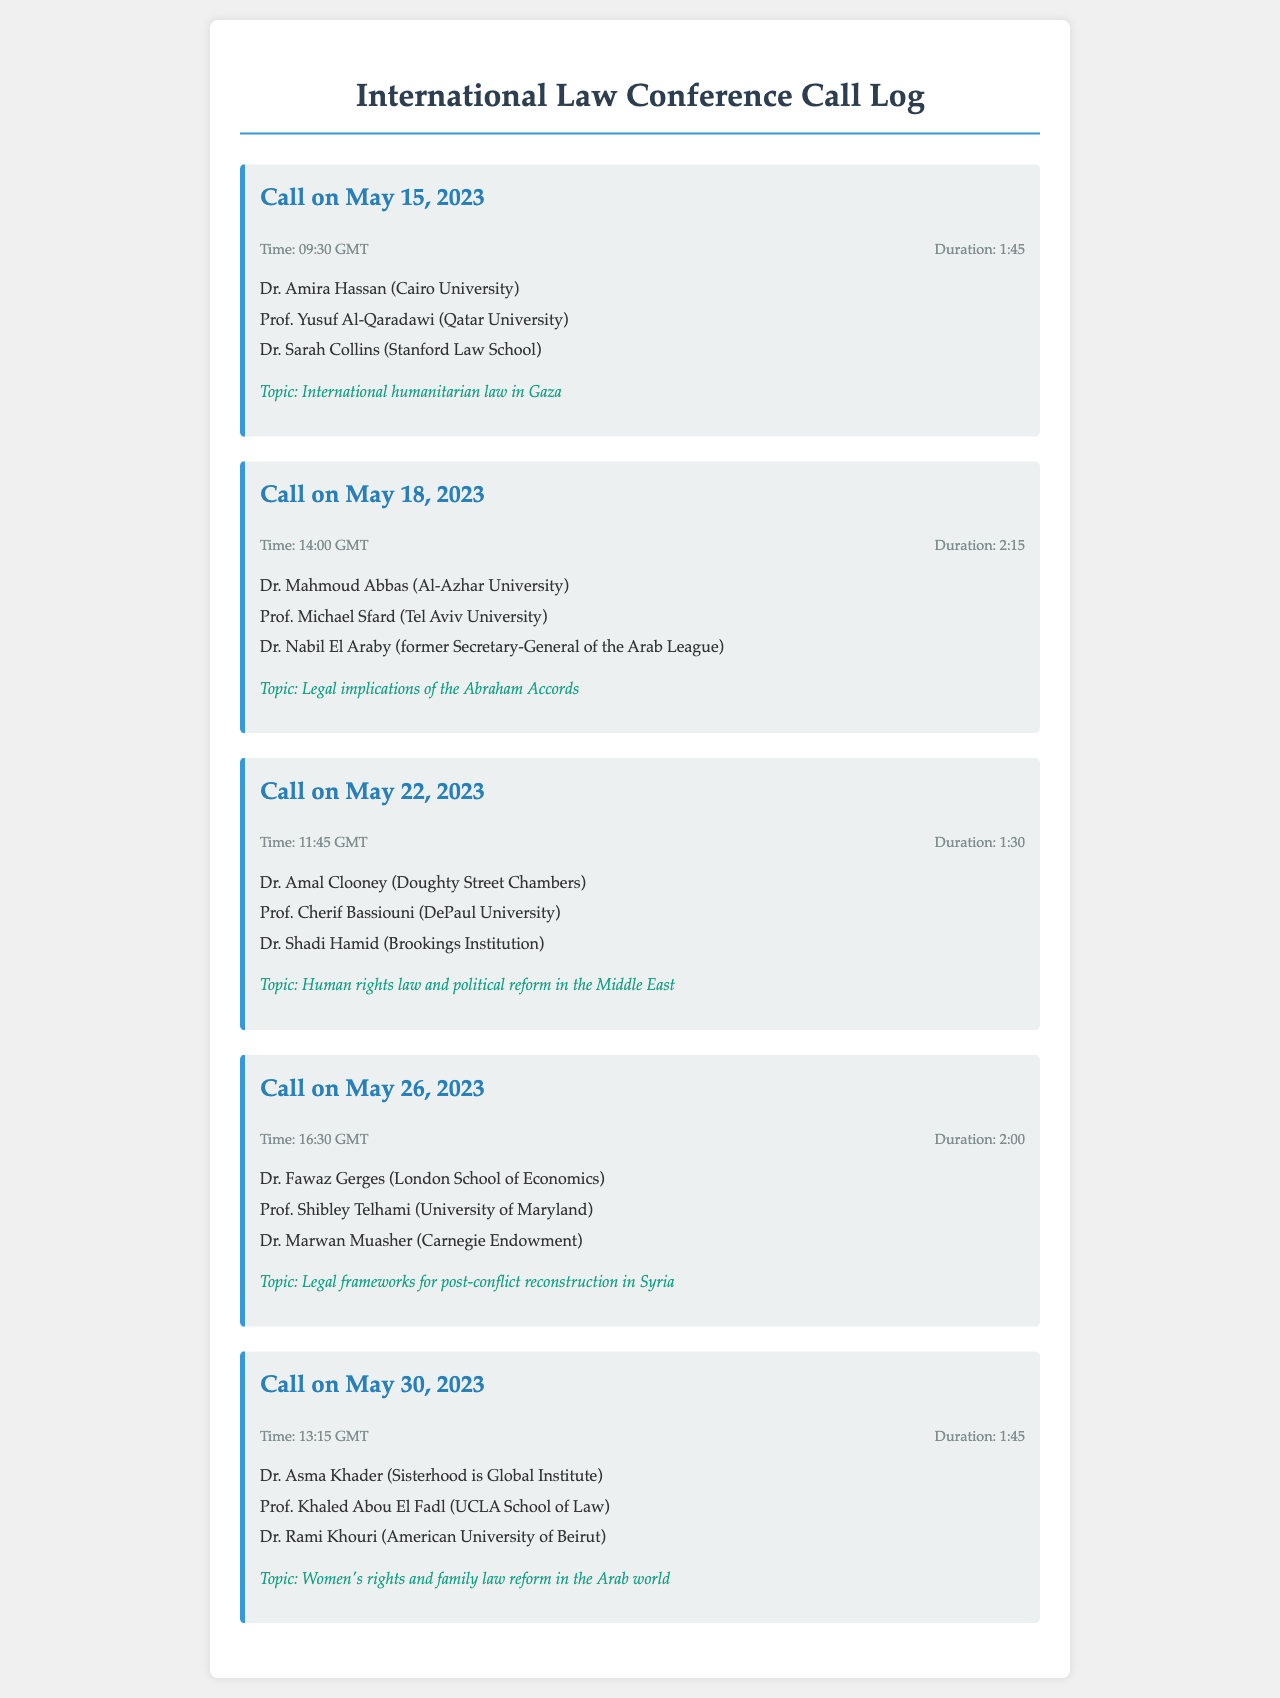What is the duration of the call on May 15, 2023? The duration of the call on May 15, 2023, is specified in the document as 1:45.
Answer: 1:45 Who participated in the discussion about international humanitarian law in Gaza? The participants of the call on May 15, 2023, are listed in the document as Dr. Amira Hassan, Prof. Yusuf Al-Qaradawi, and Dr. Sarah Collins.
Answer: Dr. Amira Hassan, Prof. Yusuf Al-Qaradawi, Dr. Sarah Collins What was the topic of the call held on May 26, 2023? The document specifies that the topic of the call on May 26, 2023, is legal frameworks for post-conflict reconstruction in Syria.
Answer: Legal frameworks for post-conflict reconstruction in Syria Which professor participated in the call regarding women's rights and family law reform? The document indicates that Prof. Khaled Abou El Fadl participated in the call on May 30, 2023, about women's rights and family law reform.
Answer: Prof. Khaled Abou El Fadl What is the total number of calls listed in the document? The document contains a total of five calls, each detailed within the entries.
Answer: 5 